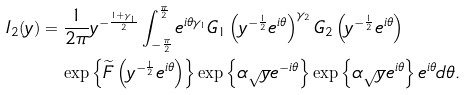<formula> <loc_0><loc_0><loc_500><loc_500>I _ { 2 } ( y ) & = \frac { 1 } { 2 \pi } y ^ { - \frac { 1 + \gamma _ { 1 } } { 2 } } \int _ { - \frac { \pi } { 2 } } ^ { \frac { \pi } { 2 } } e ^ { i \theta \gamma _ { 1 } } G _ { 1 } \left ( y ^ { - \frac { 1 } { 2 } } e ^ { i \theta } \right ) ^ { \gamma _ { 2 } } G _ { 2 } \left ( y ^ { - \frac { 1 } { 2 } } e ^ { i \theta } \right ) \\ & \quad \exp \left \{ \widetilde { F } \left ( y ^ { - \frac { 1 } { 2 } } e ^ { i \theta } \right ) \right \} \exp \left \{ \alpha \sqrt { y } e ^ { - i \theta } \right \} \exp \left \{ \alpha \sqrt { y } e ^ { i \theta } \right \} e ^ { i \theta } d \theta .</formula> 